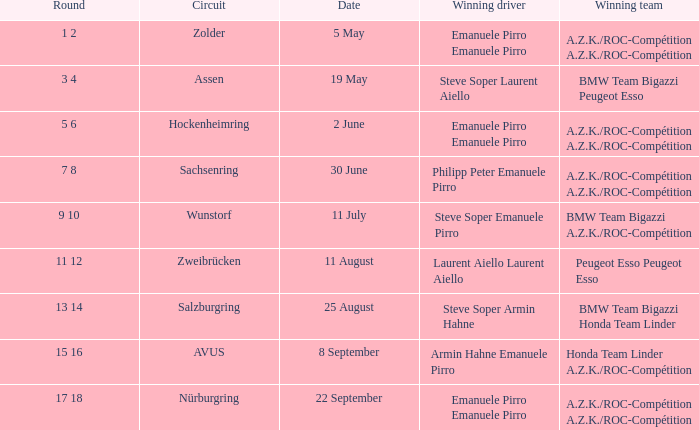What was the winning team on 11 July? BMW Team Bigazzi A.Z.K./ROC-Compétition. 